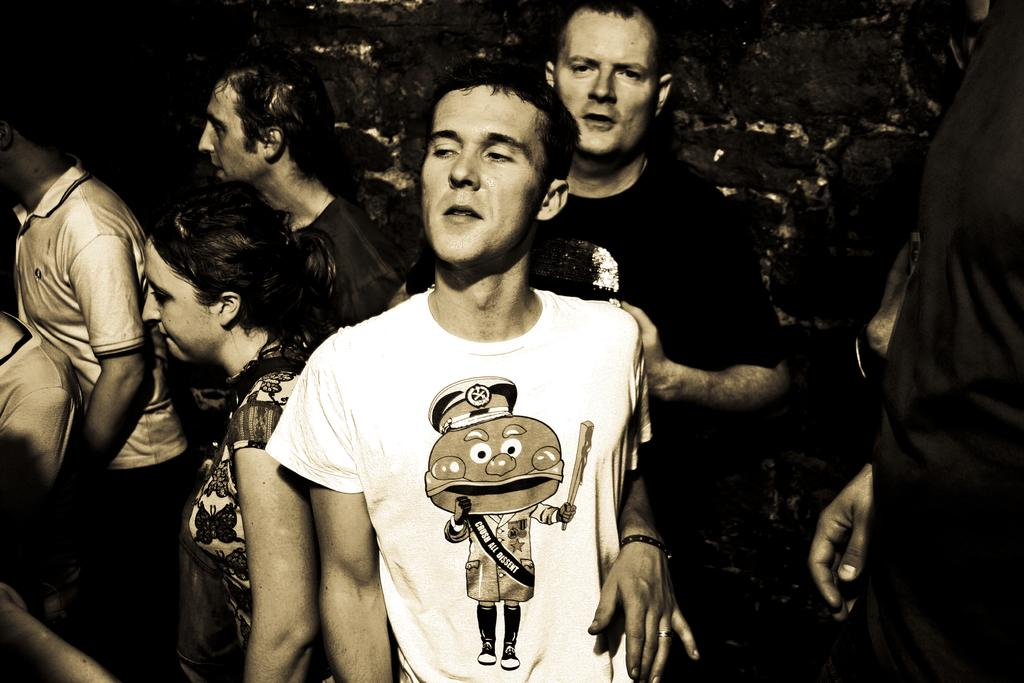How many people are in the image? The number of people in the image cannot be determined from the provided fact. What type of gold jewelry is the person wearing in the image? There is no mention of gold jewelry or any jewelry in the image, so it cannot be determined from the provided fact. 